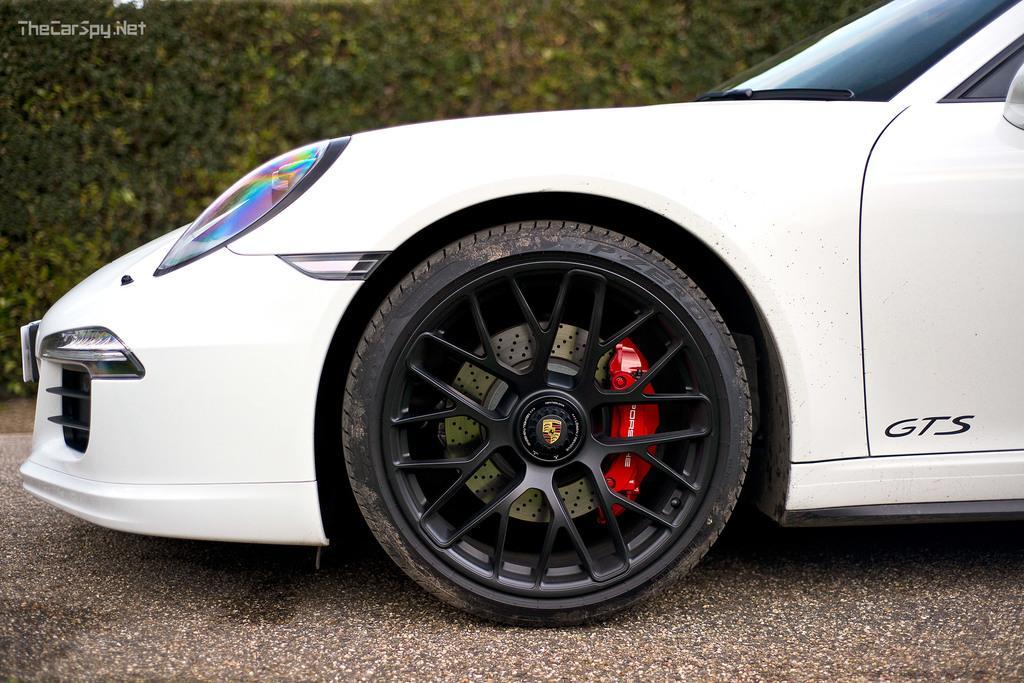In one or two sentences, can you explain what this image depicts? In the image I can see a car to which there is a wheel and to the side there are some plants. 